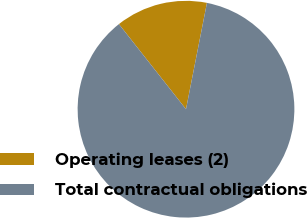Convert chart to OTSL. <chart><loc_0><loc_0><loc_500><loc_500><pie_chart><fcel>Operating leases (2)<fcel>Total contractual obligations<nl><fcel>13.72%<fcel>86.28%<nl></chart> 